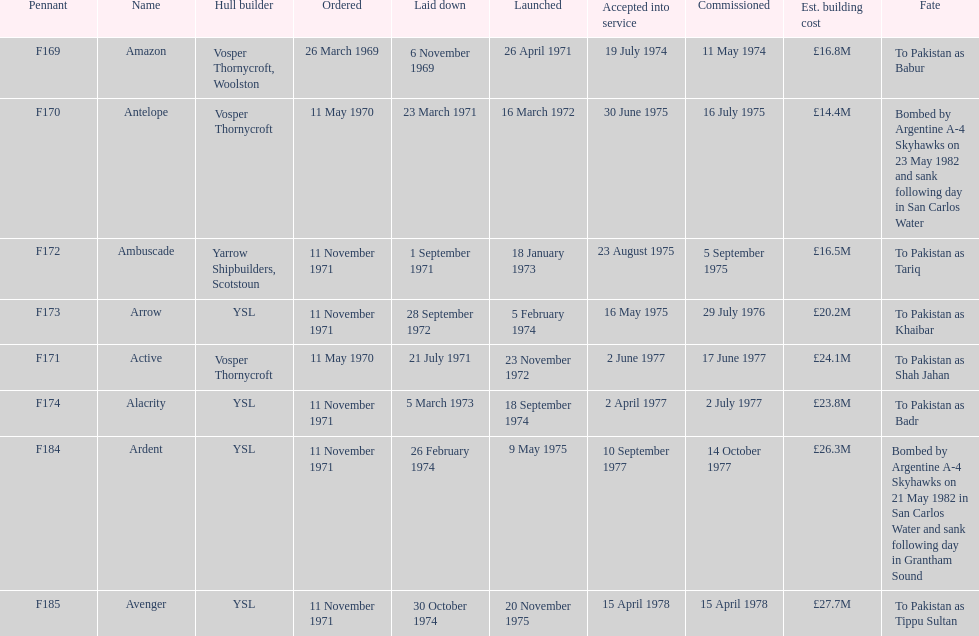How many ships were constructed subsequent to ardent? 1. 